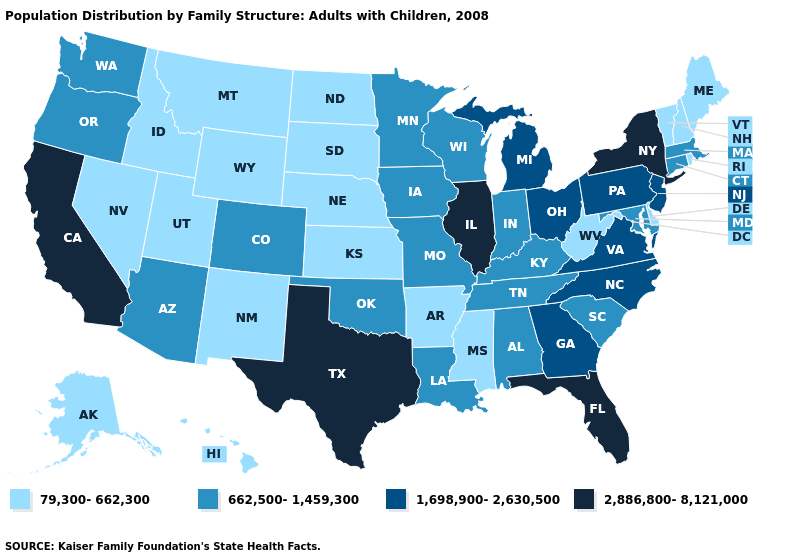Is the legend a continuous bar?
Answer briefly. No. What is the lowest value in states that border Wisconsin?
Quick response, please. 662,500-1,459,300. What is the value of Connecticut?
Answer briefly. 662,500-1,459,300. Does Colorado have the highest value in the USA?
Short answer required. No. What is the highest value in the MidWest ?
Keep it brief. 2,886,800-8,121,000. Does the map have missing data?
Quick response, please. No. Among the states that border Florida , does Georgia have the highest value?
Quick response, please. Yes. Name the states that have a value in the range 79,300-662,300?
Short answer required. Alaska, Arkansas, Delaware, Hawaii, Idaho, Kansas, Maine, Mississippi, Montana, Nebraska, Nevada, New Hampshire, New Mexico, North Dakota, Rhode Island, South Dakota, Utah, Vermont, West Virginia, Wyoming. Among the states that border Florida , does Georgia have the highest value?
Be succinct. Yes. Does Maine have the highest value in the Northeast?
Write a very short answer. No. Name the states that have a value in the range 1,698,900-2,630,500?
Keep it brief. Georgia, Michigan, New Jersey, North Carolina, Ohio, Pennsylvania, Virginia. Does Washington have the highest value in the USA?
Concise answer only. No. Name the states that have a value in the range 79,300-662,300?
Write a very short answer. Alaska, Arkansas, Delaware, Hawaii, Idaho, Kansas, Maine, Mississippi, Montana, Nebraska, Nevada, New Hampshire, New Mexico, North Dakota, Rhode Island, South Dakota, Utah, Vermont, West Virginia, Wyoming. How many symbols are there in the legend?
Give a very brief answer. 4. Which states have the highest value in the USA?
Concise answer only. California, Florida, Illinois, New York, Texas. 